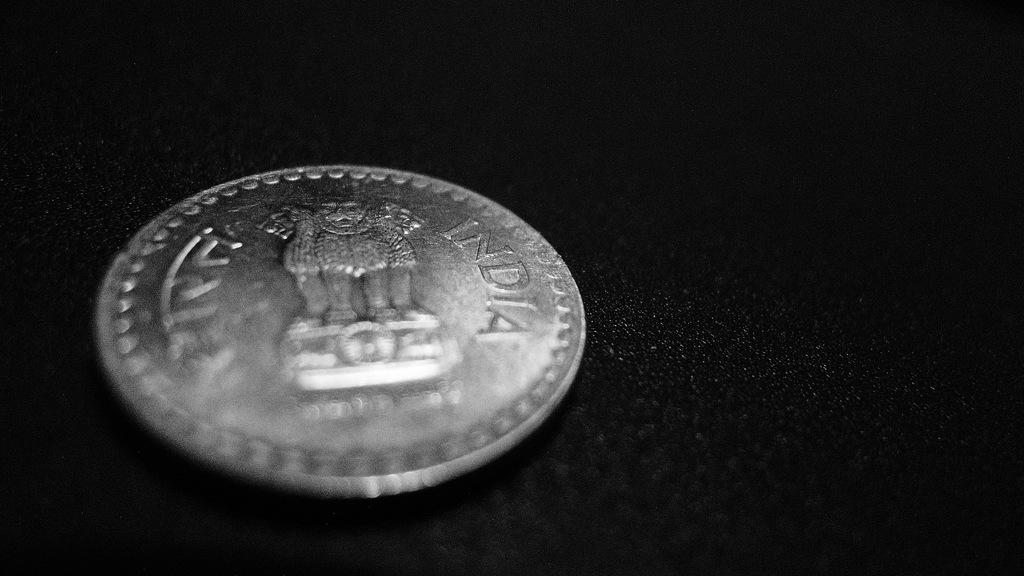<image>
Provide a brief description of the given image. A silver coin from India is lying on a black background. 